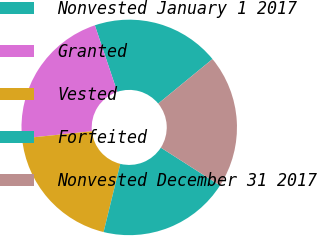Convert chart to OTSL. <chart><loc_0><loc_0><loc_500><loc_500><pie_chart><fcel>Nonvested January 1 2017<fcel>Granted<fcel>Vested<fcel>Forfeited<fcel>Nonvested December 31 2017<nl><fcel>19.23%<fcel>21.47%<fcel>19.54%<fcel>19.77%<fcel>19.99%<nl></chart> 